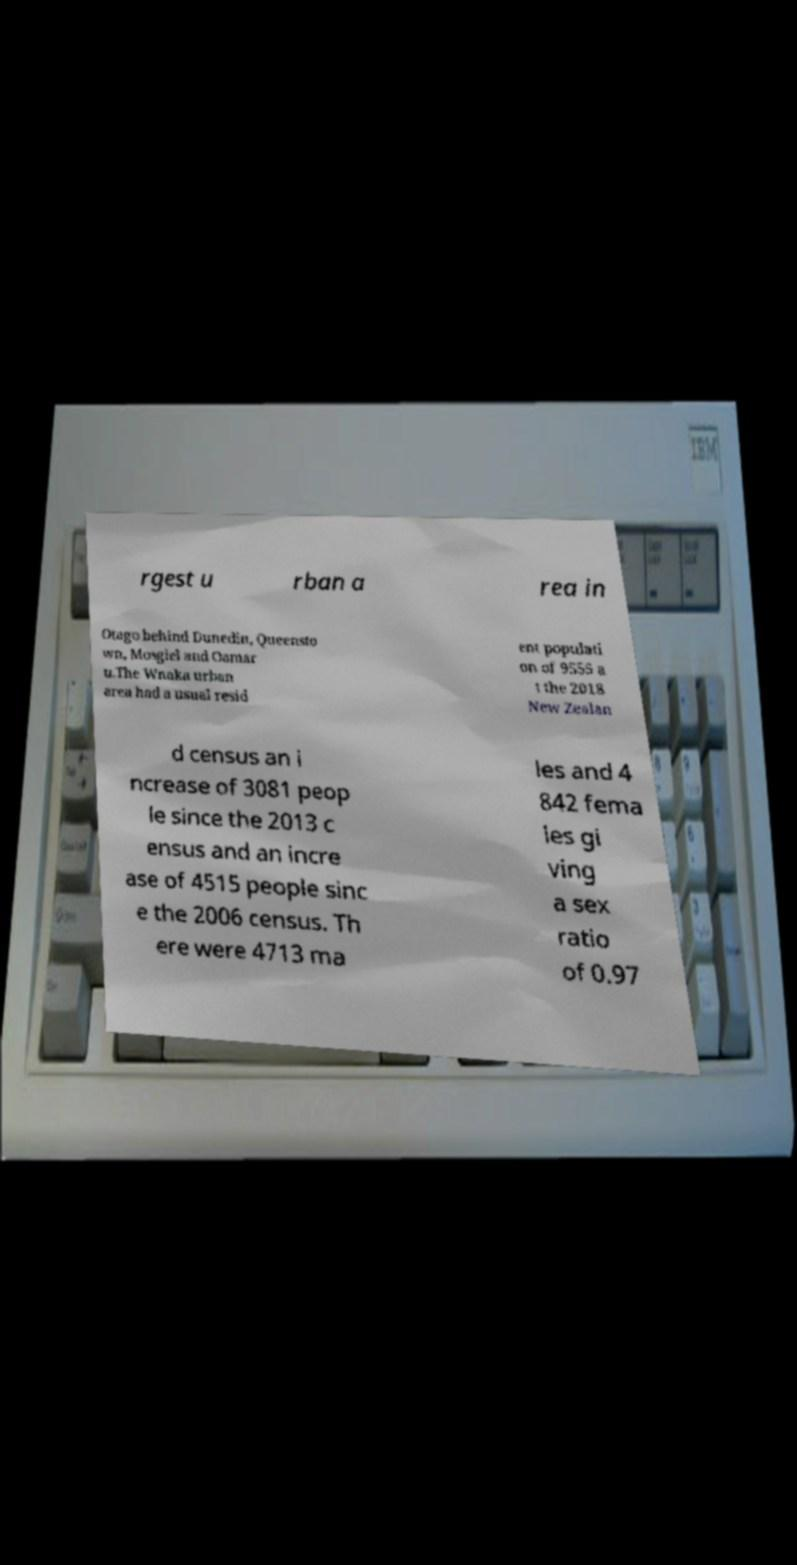Can you accurately transcribe the text from the provided image for me? rgest u rban a rea in Otago behind Dunedin, Queensto wn, Mosgiel and Oamar u.The Wnaka urban area had a usual resid ent populati on of 9555 a t the 2018 New Zealan d census an i ncrease of 3081 peop le since the 2013 c ensus and an incre ase of 4515 people sinc e the 2006 census. Th ere were 4713 ma les and 4 842 fema les gi ving a sex ratio of 0.97 